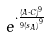Convert formula to latex. <formula><loc_0><loc_0><loc_500><loc_500>e ^ { \cdot \frac { ( A \cdot C ) ^ { 9 } } { 9 { ( s _ { A } ) } ^ { 9 } } }</formula> 